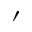<formula> <loc_0><loc_0><loc_500><loc_500>\prime</formula> 